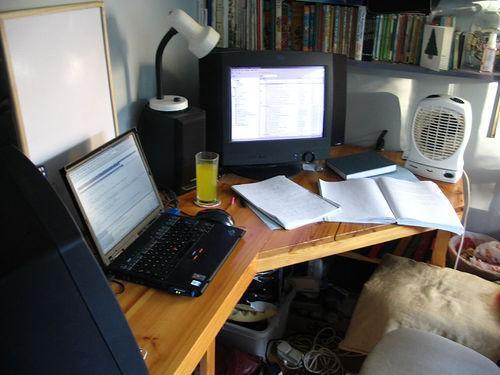How many chairs are there?
Give a very brief answer. 2. How many books are visible?
Give a very brief answer. 4. How many tvs can you see?
Give a very brief answer. 2. 